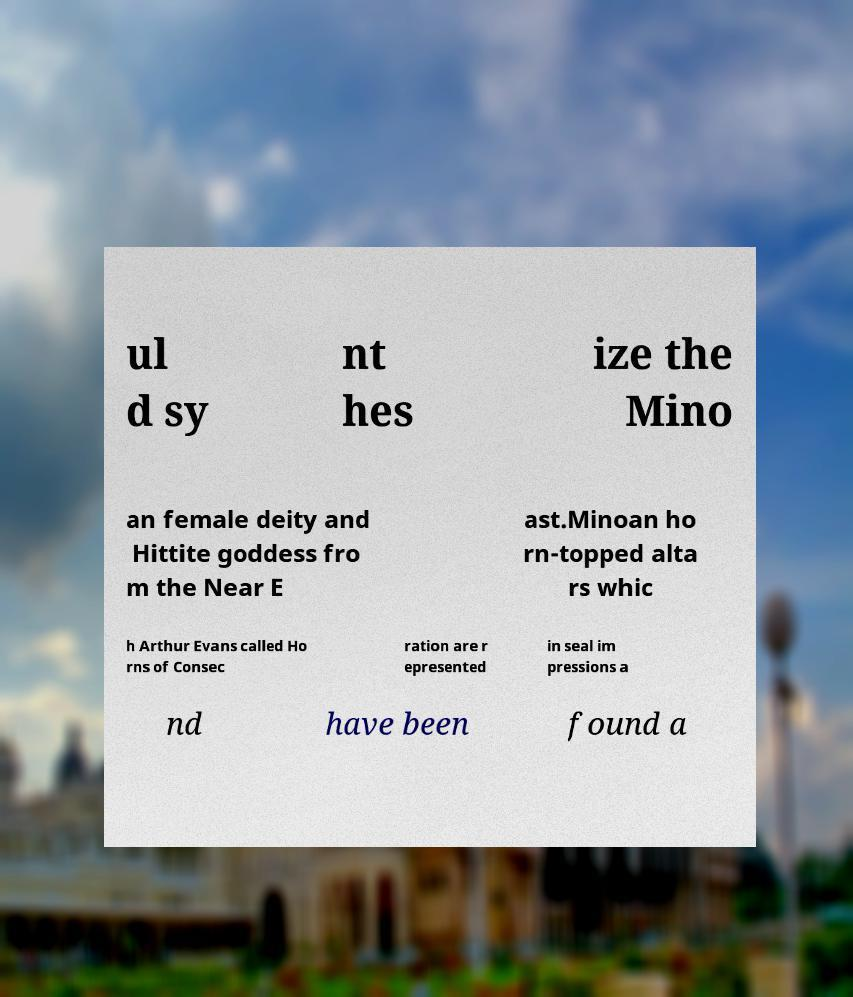Can you read and provide the text displayed in the image?This photo seems to have some interesting text. Can you extract and type it out for me? ul d sy nt hes ize the Mino an female deity and Hittite goddess fro m the Near E ast.Minoan ho rn-topped alta rs whic h Arthur Evans called Ho rns of Consec ration are r epresented in seal im pressions a nd have been found a 